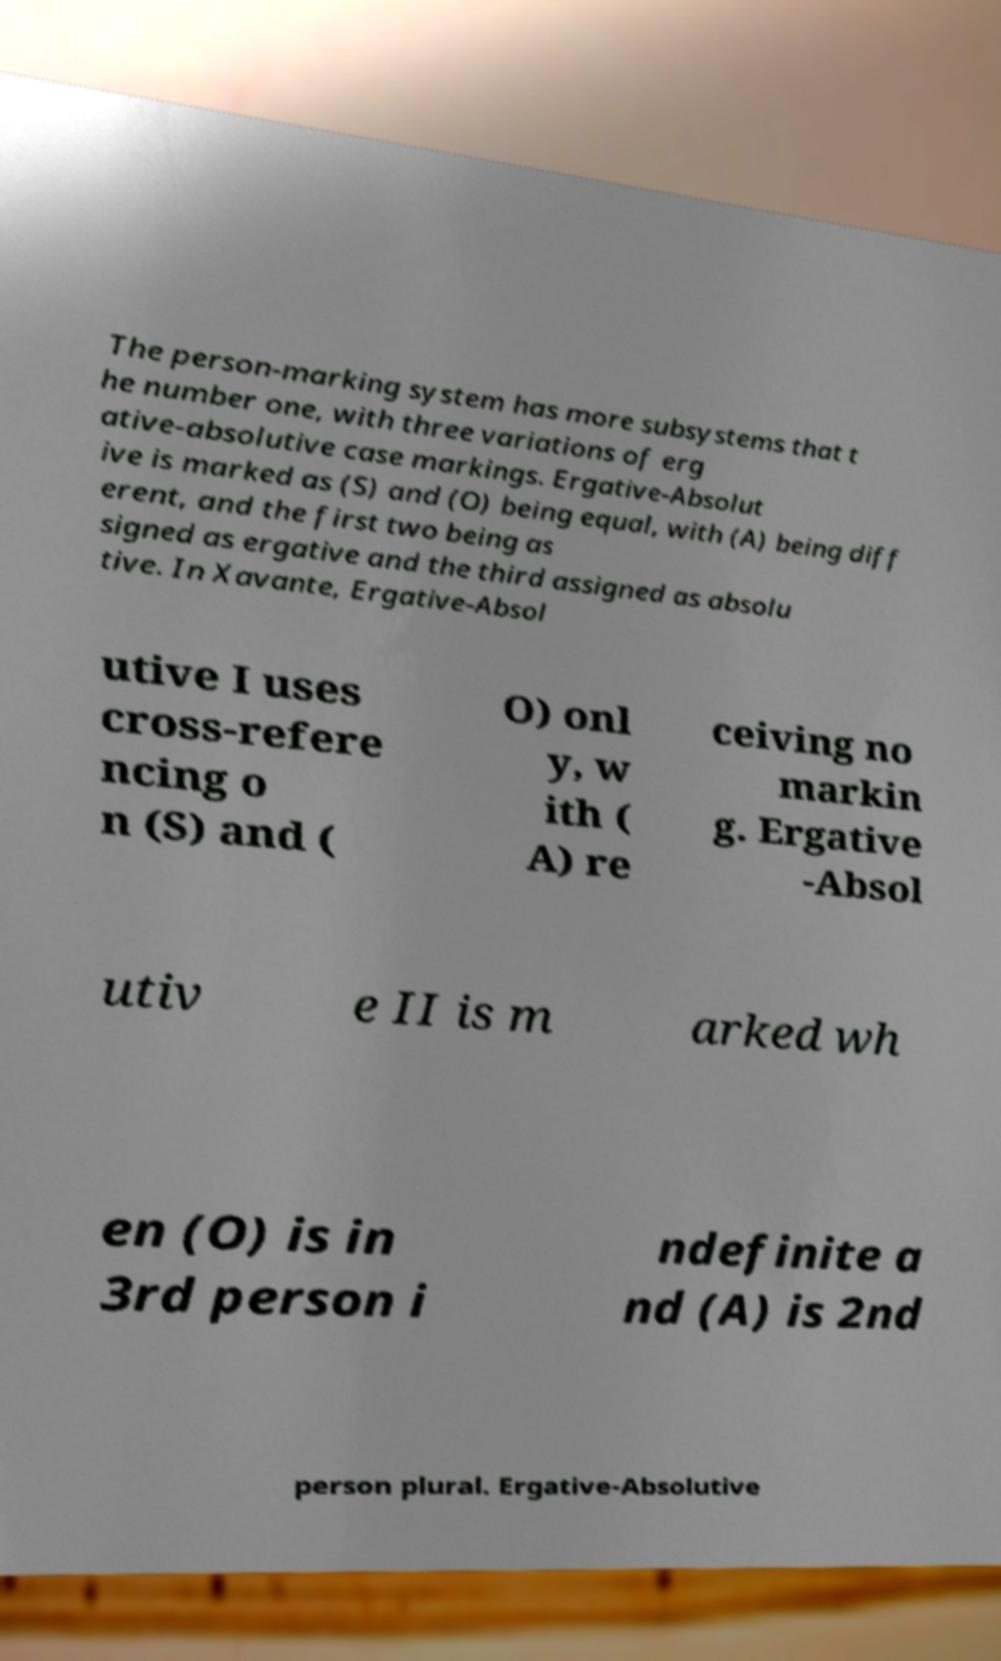What messages or text are displayed in this image? I need them in a readable, typed format. The person-marking system has more subsystems that t he number one, with three variations of erg ative-absolutive case markings. Ergative-Absolut ive is marked as (S) and (O) being equal, with (A) being diff erent, and the first two being as signed as ergative and the third assigned as absolu tive. In Xavante, Ergative-Absol utive I uses cross-refere ncing o n (S) and ( O) onl y, w ith ( A) re ceiving no markin g. Ergative -Absol utiv e II is m arked wh en (O) is in 3rd person i ndefinite a nd (A) is 2nd person plural. Ergative-Absolutive 